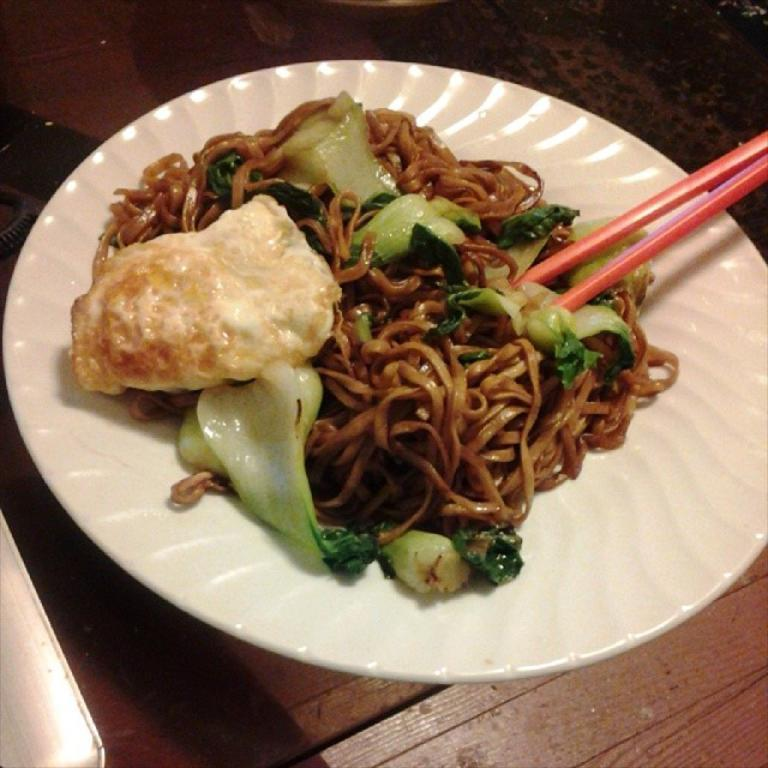What is present on the plate in the image? There is food placed on the plate in the image. What utensils are visible in the image? There are chopsticks in the image. What type of surface is at the bottom of the image? There is a wooden surface at the bottom of the image. How many cherries can be seen on the mountain in the image? There is no mountain or cherries present in the image. Is there a kitten playing with the food on the plate in the image? There is no kitten present in the image. 